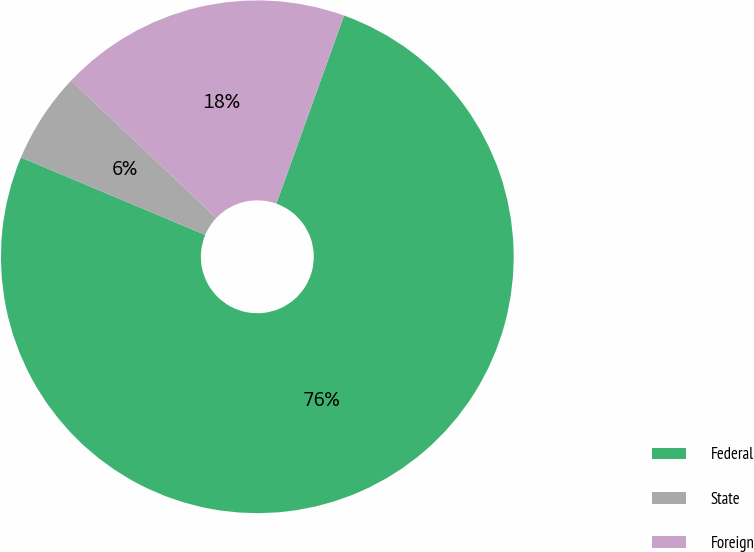<chart> <loc_0><loc_0><loc_500><loc_500><pie_chart><fcel>Federal<fcel>State<fcel>Foreign<nl><fcel>75.84%<fcel>5.73%<fcel>18.43%<nl></chart> 